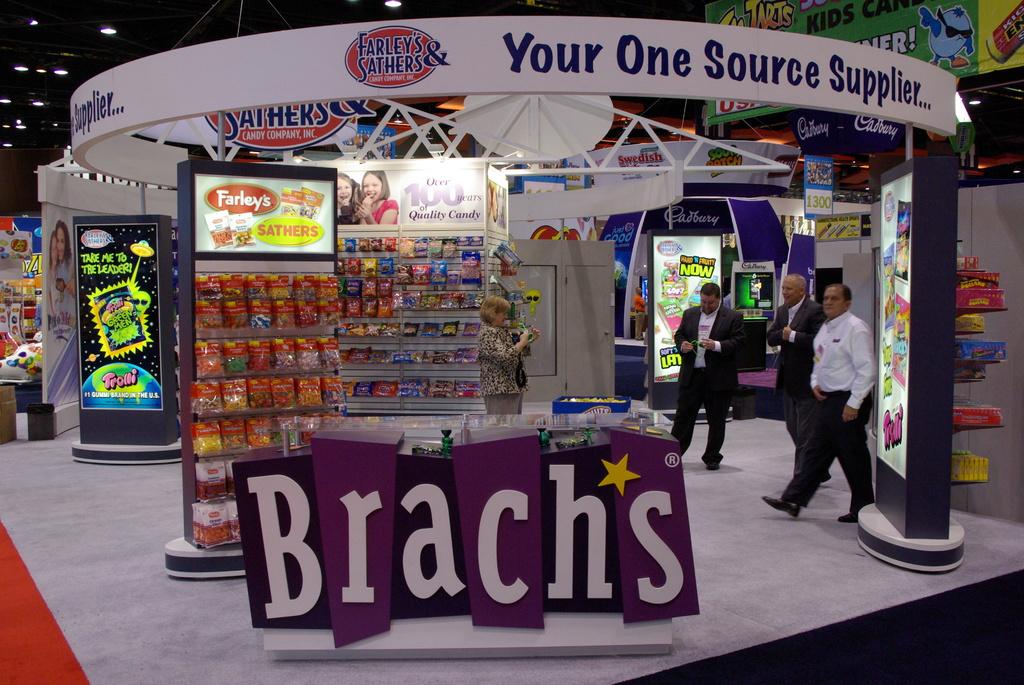What type of supplier does the store say they are?
Your response must be concise. One source. What is the name of the store/?
Offer a very short reply. Brachs. 